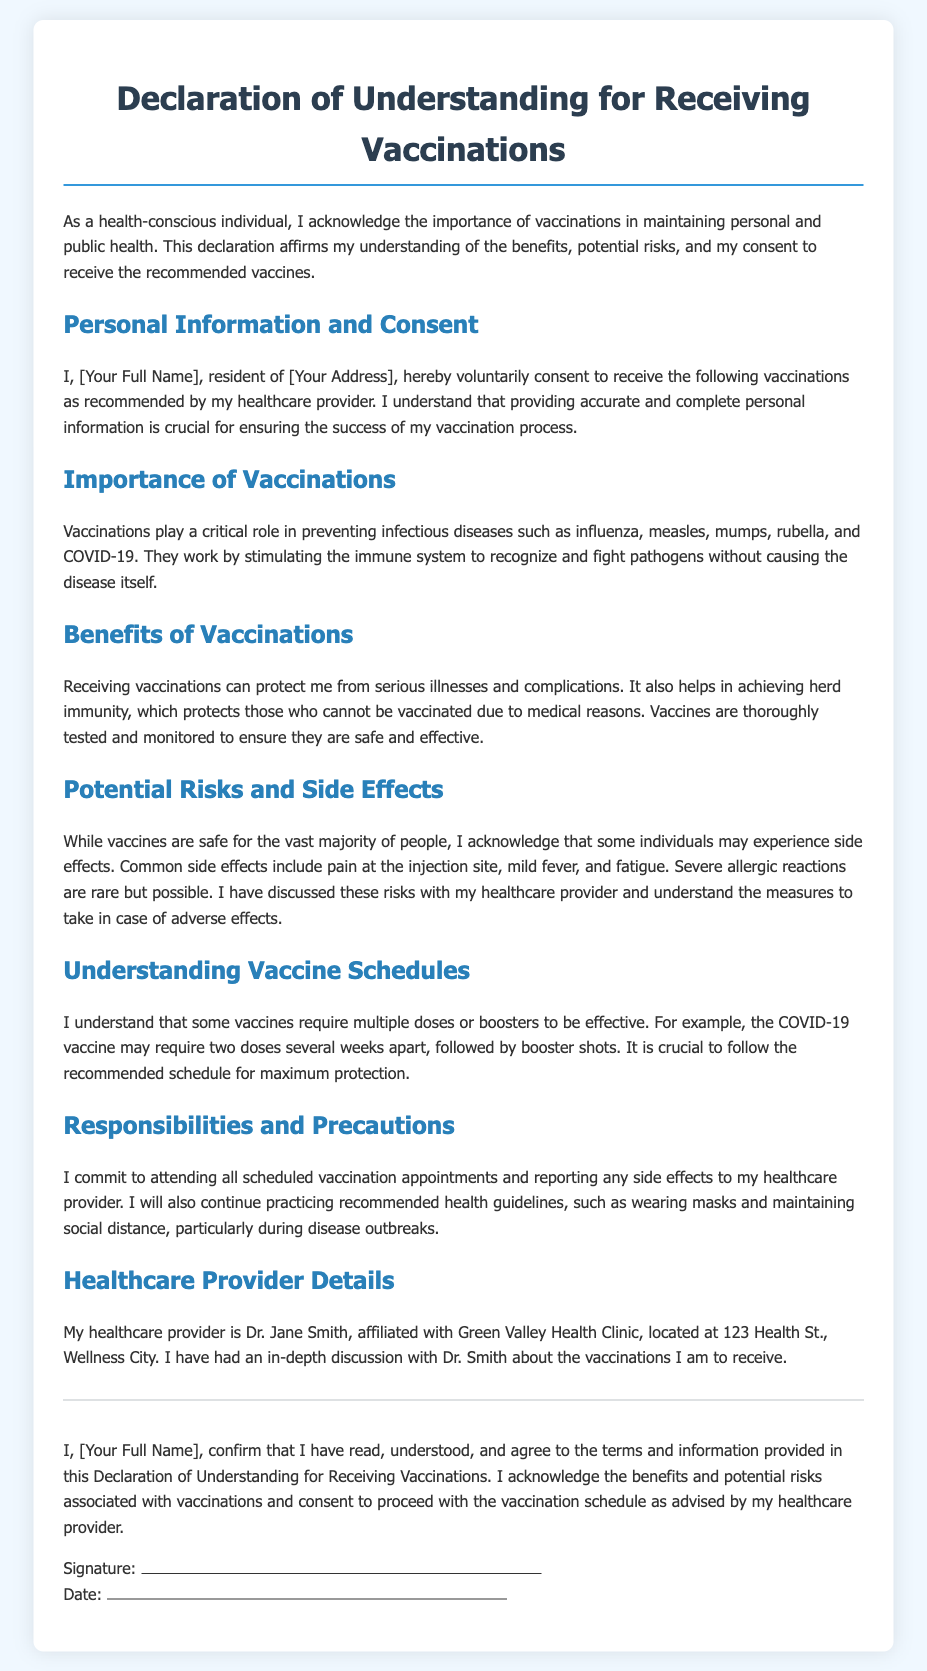What is the title of the document? The title is stated at the beginning of the document and clearly indicates its purpose.
Answer: Declaration of Understanding for Receiving Vaccinations Who is the healthcare provider mentioned in the document? The document provides the name of the healthcare provider discussed, along with some details.
Answer: Dr. Jane Smith What is the address of the healthcare provider's clinic? The address is explicitly stated in a specific section of the document.
Answer: 123 Health St., Wellness City What are some common side effects of vaccines mentioned? The document lists specific side effects, showing an understanding of potential reactions.
Answer: Pain at the injection site, mild fever, and fatigue What is required to achieve maximum protection from vaccines? The document includes information about the necessary actions to be effective.
Answer: Following the recommended schedule What should be reported to the healthcare provider after vaccination? This information is crucial for monitoring vaccination effects and ensuring health safety.
Answer: Any side effects What is the significance of herd immunity mentioned in the benefits? This question requires an understanding of the broader impact of individual vaccinations on the community.
Answer: Protects those who cannot be vaccinated due to medical reasons What does the individual confirm by signing the document? The signature section indicates the person's understanding and agreement to the document's content.
Answer: Read, understood, and agree to the terms and information provided 